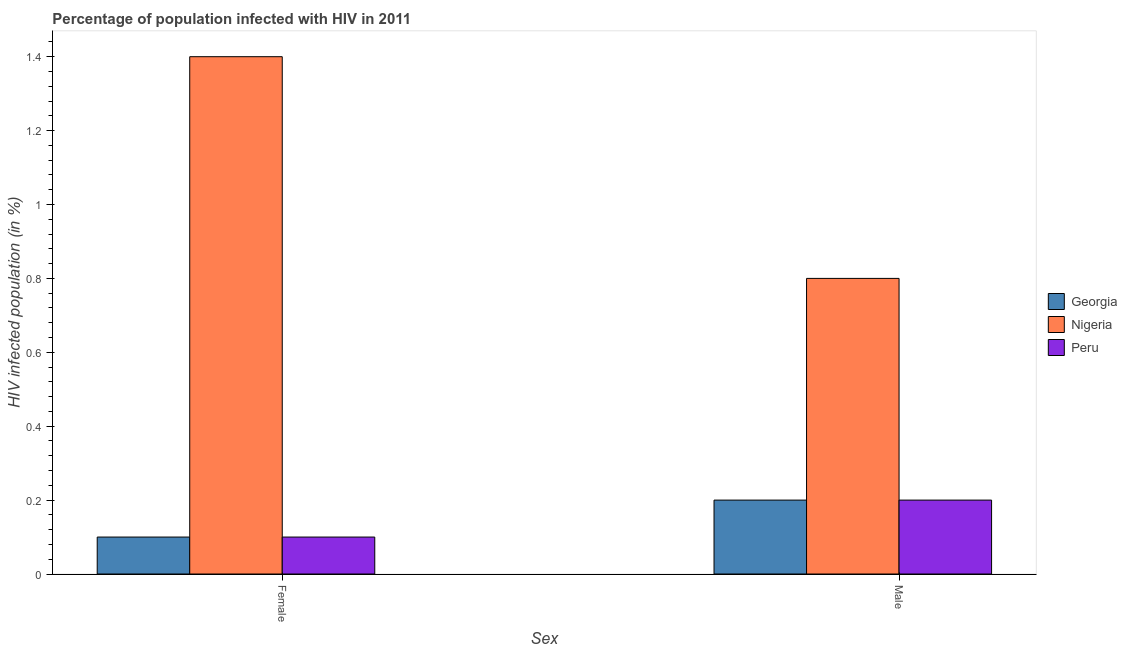How many different coloured bars are there?
Give a very brief answer. 3. How many groups of bars are there?
Ensure brevity in your answer.  2. Are the number of bars per tick equal to the number of legend labels?
Make the answer very short. Yes. Are the number of bars on each tick of the X-axis equal?
Offer a very short reply. Yes. What is the label of the 1st group of bars from the left?
Offer a terse response. Female. In which country was the percentage of males who are infected with hiv maximum?
Your response must be concise. Nigeria. In which country was the percentage of females who are infected with hiv minimum?
Ensure brevity in your answer.  Georgia. What is the total percentage of males who are infected with hiv in the graph?
Your answer should be very brief. 1.2. What is the difference between the percentage of males who are infected with hiv in Georgia and that in Nigeria?
Provide a short and direct response. -0.6. What is the average percentage of females who are infected with hiv per country?
Your answer should be very brief. 0.53. What is the difference between the percentage of females who are infected with hiv and percentage of males who are infected with hiv in Nigeria?
Provide a succinct answer. 0.6. What is the ratio of the percentage of females who are infected with hiv in Peru to that in Nigeria?
Ensure brevity in your answer.  0.07. What does the 1st bar from the left in Male represents?
Keep it short and to the point. Georgia. What does the 3rd bar from the right in Male represents?
Ensure brevity in your answer.  Georgia. Are all the bars in the graph horizontal?
Ensure brevity in your answer.  No. Does the graph contain any zero values?
Keep it short and to the point. No. Where does the legend appear in the graph?
Your response must be concise. Center right. How are the legend labels stacked?
Ensure brevity in your answer.  Vertical. What is the title of the graph?
Provide a short and direct response. Percentage of population infected with HIV in 2011. What is the label or title of the X-axis?
Offer a very short reply. Sex. What is the label or title of the Y-axis?
Your answer should be compact. HIV infected population (in %). What is the HIV infected population (in %) in Georgia in Female?
Your answer should be very brief. 0.1. What is the HIV infected population (in %) in Peru in Female?
Ensure brevity in your answer.  0.1. What is the HIV infected population (in %) of Georgia in Male?
Ensure brevity in your answer.  0.2. Across all Sex, what is the maximum HIV infected population (in %) of Georgia?
Ensure brevity in your answer.  0.2. Across all Sex, what is the minimum HIV infected population (in %) in Georgia?
Your answer should be compact. 0.1. Across all Sex, what is the minimum HIV infected population (in %) of Nigeria?
Your response must be concise. 0.8. Across all Sex, what is the minimum HIV infected population (in %) of Peru?
Make the answer very short. 0.1. What is the total HIV infected population (in %) of Nigeria in the graph?
Offer a terse response. 2.2. What is the total HIV infected population (in %) of Peru in the graph?
Give a very brief answer. 0.3. What is the difference between the HIV infected population (in %) of Peru in Female and that in Male?
Provide a short and direct response. -0.1. What is the average HIV infected population (in %) of Nigeria per Sex?
Your answer should be very brief. 1.1. What is the average HIV infected population (in %) of Peru per Sex?
Your response must be concise. 0.15. What is the difference between the HIV infected population (in %) in Georgia and HIV infected population (in %) in Nigeria in Female?
Give a very brief answer. -1.3. What is the difference between the HIV infected population (in %) in Georgia and HIV infected population (in %) in Peru in Female?
Your answer should be very brief. 0. What is the difference between the HIV infected population (in %) in Nigeria and HIV infected population (in %) in Peru in Female?
Provide a short and direct response. 1.3. What is the difference between the HIV infected population (in %) of Georgia and HIV infected population (in %) of Nigeria in Male?
Make the answer very short. -0.6. What is the ratio of the HIV infected population (in %) in Peru in Female to that in Male?
Make the answer very short. 0.5. What is the difference between the highest and the second highest HIV infected population (in %) in Nigeria?
Ensure brevity in your answer.  0.6. What is the difference between the highest and the lowest HIV infected population (in %) in Nigeria?
Give a very brief answer. 0.6. What is the difference between the highest and the lowest HIV infected population (in %) of Peru?
Make the answer very short. 0.1. 